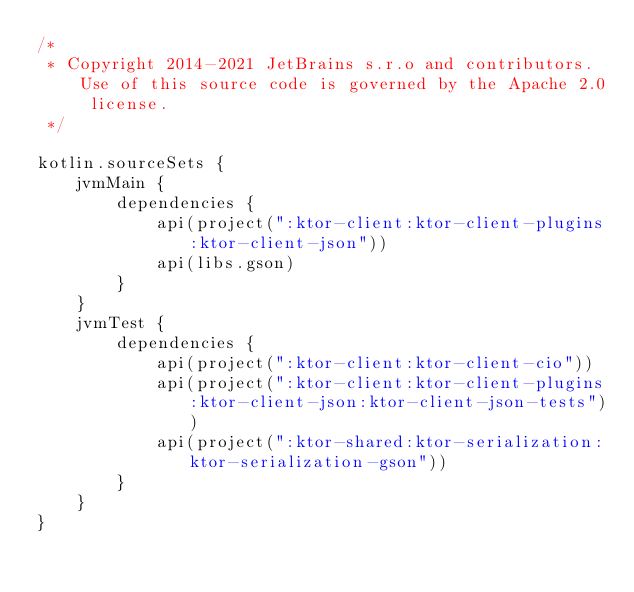Convert code to text. <code><loc_0><loc_0><loc_500><loc_500><_Kotlin_>/*
 * Copyright 2014-2021 JetBrains s.r.o and contributors. Use of this source code is governed by the Apache 2.0 license.
 */

kotlin.sourceSets {
    jvmMain {
        dependencies {
            api(project(":ktor-client:ktor-client-plugins:ktor-client-json"))
            api(libs.gson)
        }
    }
    jvmTest {
        dependencies {
            api(project(":ktor-client:ktor-client-cio"))
            api(project(":ktor-client:ktor-client-plugins:ktor-client-json:ktor-client-json-tests"))
            api(project(":ktor-shared:ktor-serialization:ktor-serialization-gson"))
        }
    }
}
</code> 